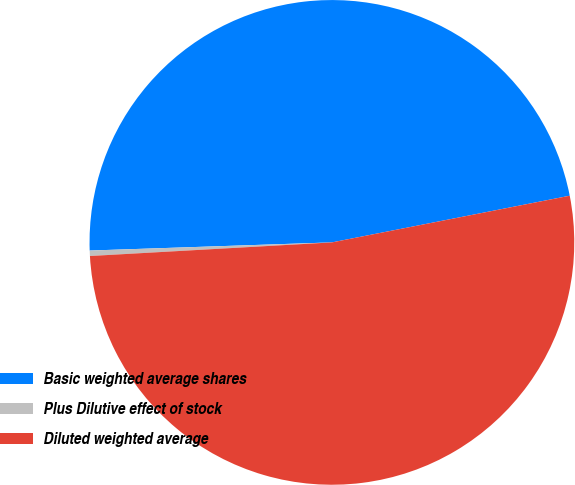<chart> <loc_0><loc_0><loc_500><loc_500><pie_chart><fcel>Basic weighted average shares<fcel>Plus Dilutive effect of stock<fcel>Diluted weighted average<nl><fcel>47.45%<fcel>0.36%<fcel>52.19%<nl></chart> 